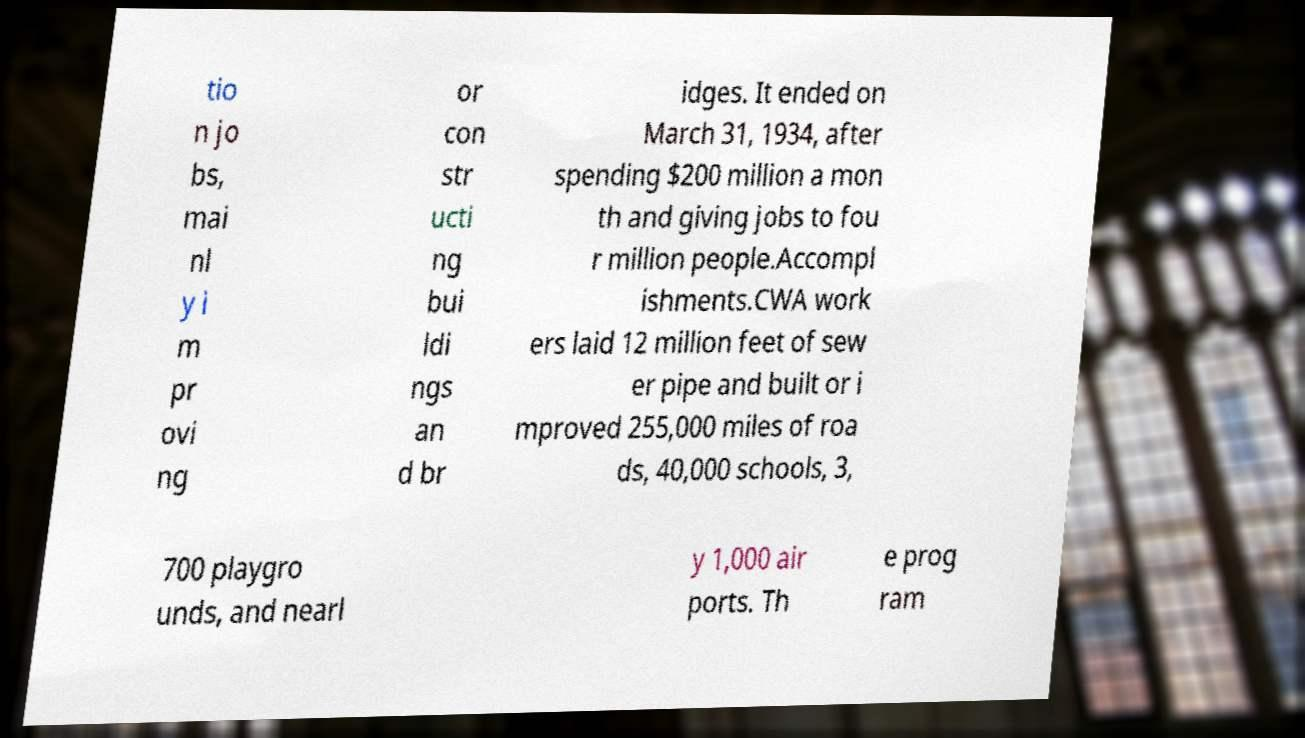Can you read and provide the text displayed in the image?This photo seems to have some interesting text. Can you extract and type it out for me? tio n jo bs, mai nl y i m pr ovi ng or con str ucti ng bui ldi ngs an d br idges. It ended on March 31, 1934, after spending $200 million a mon th and giving jobs to fou r million people.Accompl ishments.CWA work ers laid 12 million feet of sew er pipe and built or i mproved 255,000 miles of roa ds, 40,000 schools, 3, 700 playgro unds, and nearl y 1,000 air ports. Th e prog ram 